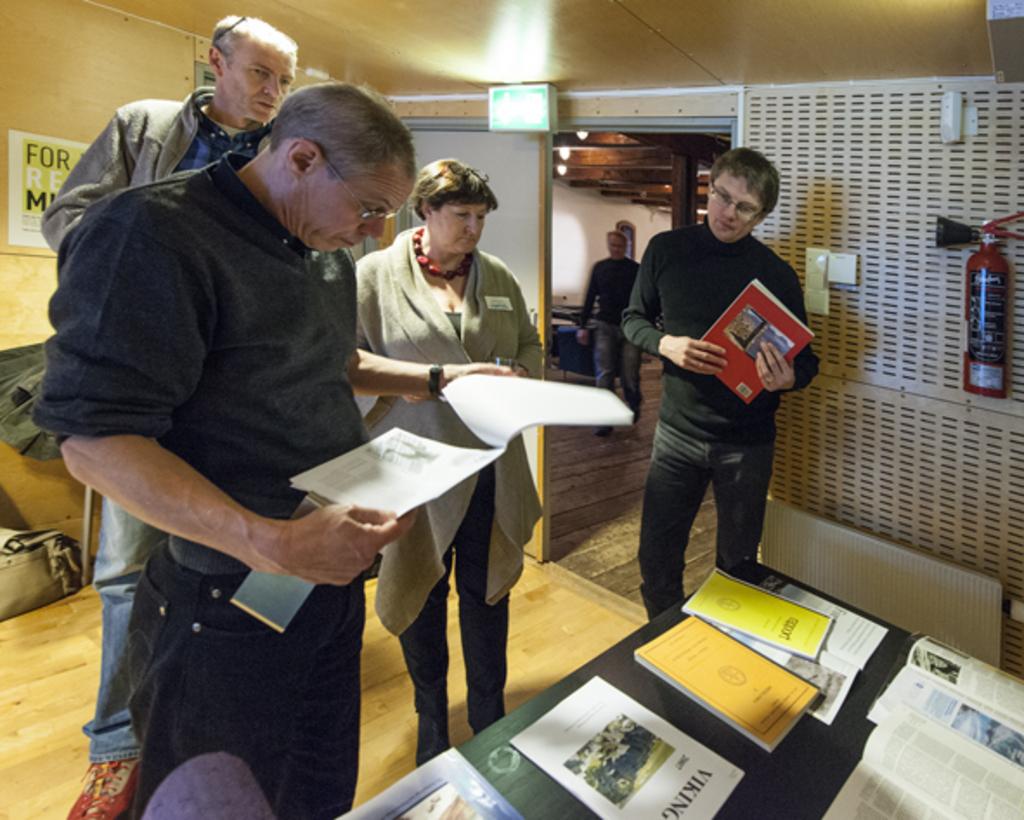What is the title of the white document on the table close to the nearby man?
Keep it short and to the point. Viking. What is the title of the 2nd  document on the table from  the left?
Offer a terse response. Viking. 